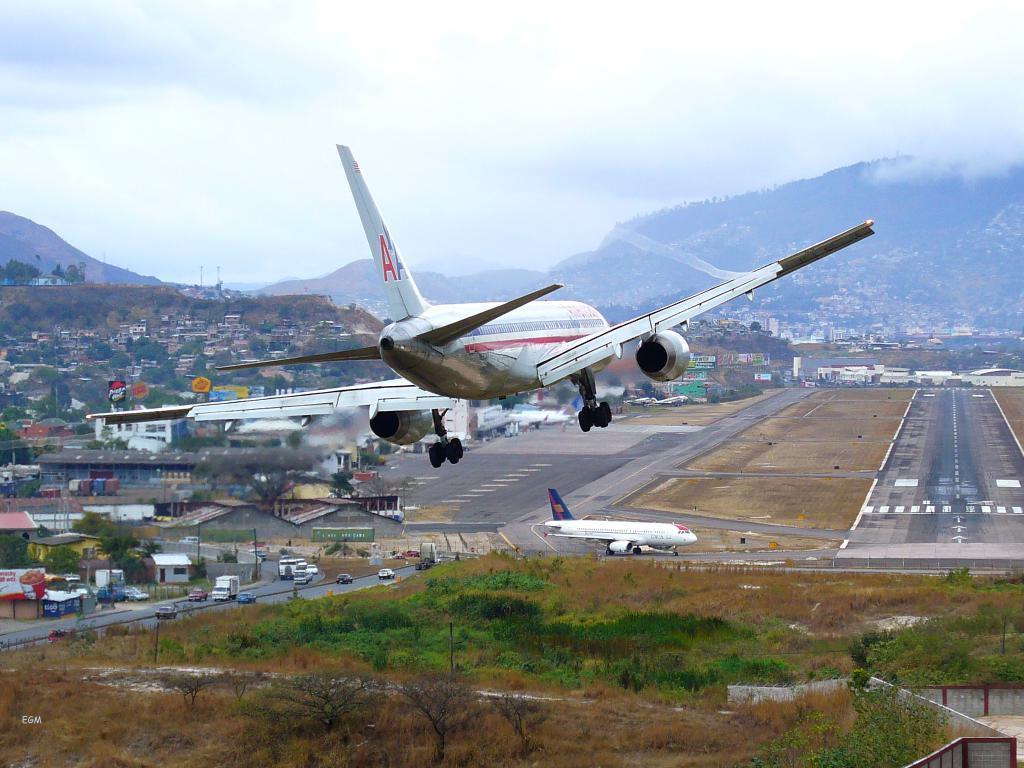Can you describe this image briefly? In this picture we can see an airplane flying in the air, buildings, trees, mountains and vehicles on the road and in the background we can see the sky with clouds. 